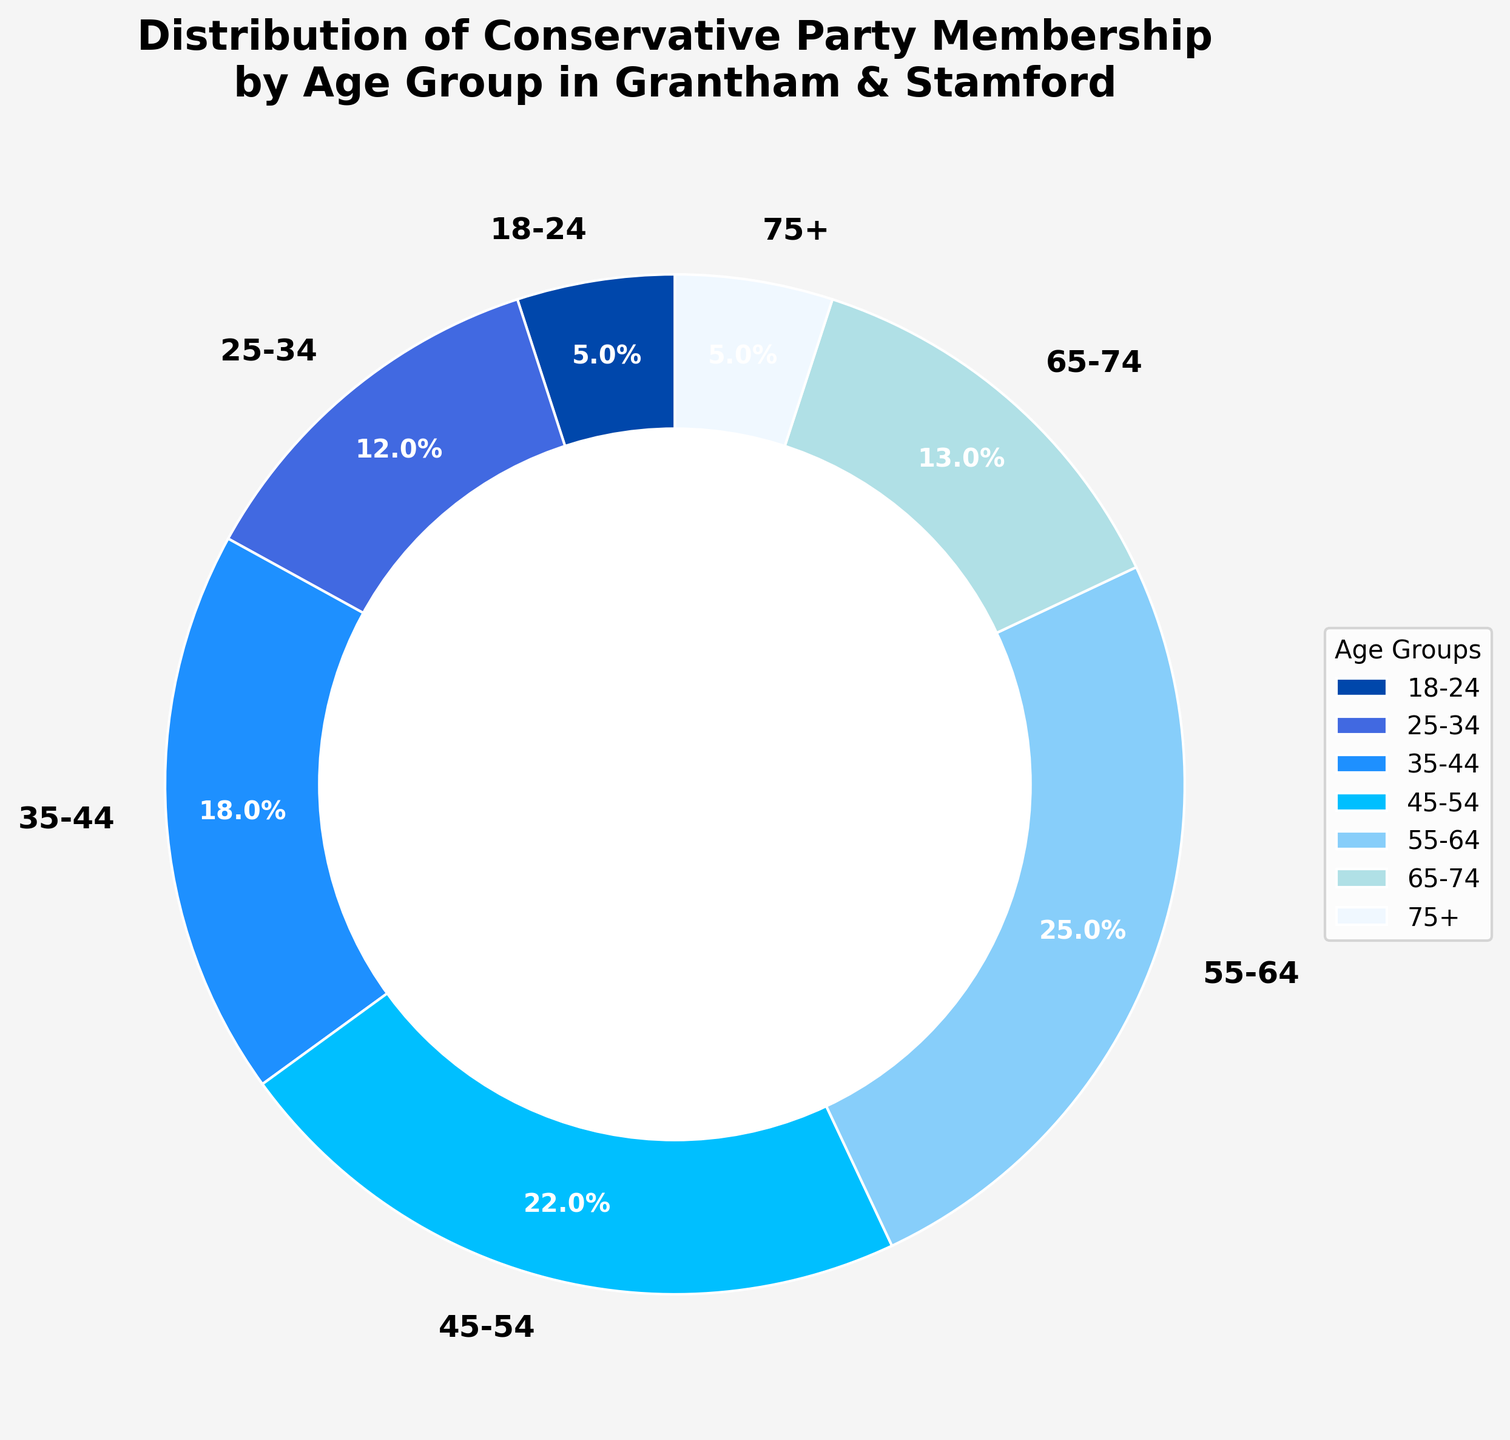Which age group has the highest percentage of Conservative Party membership in Grantham & Stamford? The closest visual inspection shows the 55-64 age group has the largest section in the pie chart, which suggests the highest percentage.
Answer: 55-64 What is the combined percentage of Conservative Party members who are 25-34 and 35-44 years old? Add the percentages of the 25-34 age group (12%) and the 35-44 age group (18%) to get the combined percentage. 12 + 18 = 30.
Answer: 30% Comparing the 18-24 and 75+ age groups, which has more party members and by how much? Both 18-24 and 75+ age groups have the same percentage (5%). Therefore, there is no difference between them.
Answer: Same percentage, no difference Which two consecutive age groups have the smallest difference in their membership percentages? Visually inspect the pie chart and find the smallest difference between consecutive age groups. 65-74 (13%) and 75+ (5%) yield a difference of 8%. Other differences are larger, such as between 55-64 (25%) and 65-74 (13%) which is 12%.
Answer: 65-74 and 75+, difference is 8% Is the combined percentage of the age groups above 55 years more or less than 45%? Add the percentages 55-64 (25%), 65-74 (13%), and 75+ (5%) to find the total. 25 + 13 + 5 = 43%. Compare it with 45%.
Answer: Less than 45% What is the difference in percentage between the 45-54 age group and the 65-74 age group? Subtract the percentage of the 65-74 age group (13%) from the percentage of the 45-54 age group (22%). 22 - 13 = 9.
Answer: 9% Which color represents the 45-54 age group on the pie chart, and what is its percentage representation? Identify the color section representing the 45-54 age group and note down the percentage. The pie chart shows this age group in a light blue shade with a percentage of 22%.
Answer: Light blue, 22% What is the average percentage of Conservative Party membership for age groups below 55 years? Add the percentages for age groups 18-24 (5%), 25-34 (12%), 35-44 (18%), and 45-54 (22%) and then divide by the number of groups. (5 + 12 + 18 + 22) / 4 = 57 / 4 = 14.25.
Answer: 14.25% In terms of visual size on the pie chart, which age group follows directly after the 55-64 age group as the next largest? Visually inspect the pie chart, noting that the next largest section after the 55-64 group is the 45-54 group.
Answer: 45-54 If we categorize the age groups into "Young" (18-34), "Middle-aged" (35-54), and "Senior" (55+), which category has the highest total membership percentage? Add the percentages for "Young": (5 + 12 = 17%), "Middle-aged": (18 + 22 = 40%), and "Senior": (25 + 13 + 5 = 43%). Compare the totals to find the highest.
Answer: Senior, 43% 